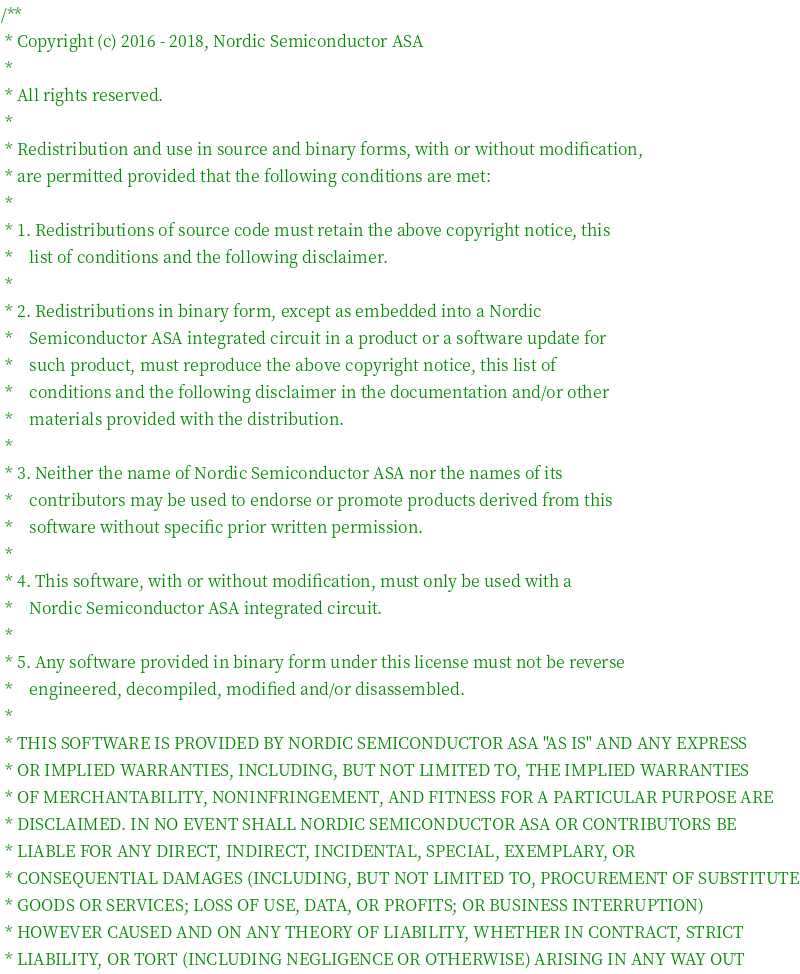<code> <loc_0><loc_0><loc_500><loc_500><_C_>/**
 * Copyright (c) 2016 - 2018, Nordic Semiconductor ASA
 *
 * All rights reserved.
 *
 * Redistribution and use in source and binary forms, with or without modification,
 * are permitted provided that the following conditions are met:
 *
 * 1. Redistributions of source code must retain the above copyright notice, this
 *    list of conditions and the following disclaimer.
 *
 * 2. Redistributions in binary form, except as embedded into a Nordic
 *    Semiconductor ASA integrated circuit in a product or a software update for
 *    such product, must reproduce the above copyright notice, this list of
 *    conditions and the following disclaimer in the documentation and/or other
 *    materials provided with the distribution.
 *
 * 3. Neither the name of Nordic Semiconductor ASA nor the names of its
 *    contributors may be used to endorse or promote products derived from this
 *    software without specific prior written permission.
 *
 * 4. This software, with or without modification, must only be used with a
 *    Nordic Semiconductor ASA integrated circuit.
 *
 * 5. Any software provided in binary form under this license must not be reverse
 *    engineered, decompiled, modified and/or disassembled.
 *
 * THIS SOFTWARE IS PROVIDED BY NORDIC SEMICONDUCTOR ASA "AS IS" AND ANY EXPRESS
 * OR IMPLIED WARRANTIES, INCLUDING, BUT NOT LIMITED TO, THE IMPLIED WARRANTIES
 * OF MERCHANTABILITY, NONINFRINGEMENT, AND FITNESS FOR A PARTICULAR PURPOSE ARE
 * DISCLAIMED. IN NO EVENT SHALL NORDIC SEMICONDUCTOR ASA OR CONTRIBUTORS BE
 * LIABLE FOR ANY DIRECT, INDIRECT, INCIDENTAL, SPECIAL, EXEMPLARY, OR
 * CONSEQUENTIAL DAMAGES (INCLUDING, BUT NOT LIMITED TO, PROCUREMENT OF SUBSTITUTE
 * GOODS OR SERVICES; LOSS OF USE, DATA, OR PROFITS; OR BUSINESS INTERRUPTION)
 * HOWEVER CAUSED AND ON ANY THEORY OF LIABILITY, WHETHER IN CONTRACT, STRICT
 * LIABILITY, OR TORT (INCLUDING NEGLIGENCE OR OTHERWISE) ARISING IN ANY WAY OUT</code> 